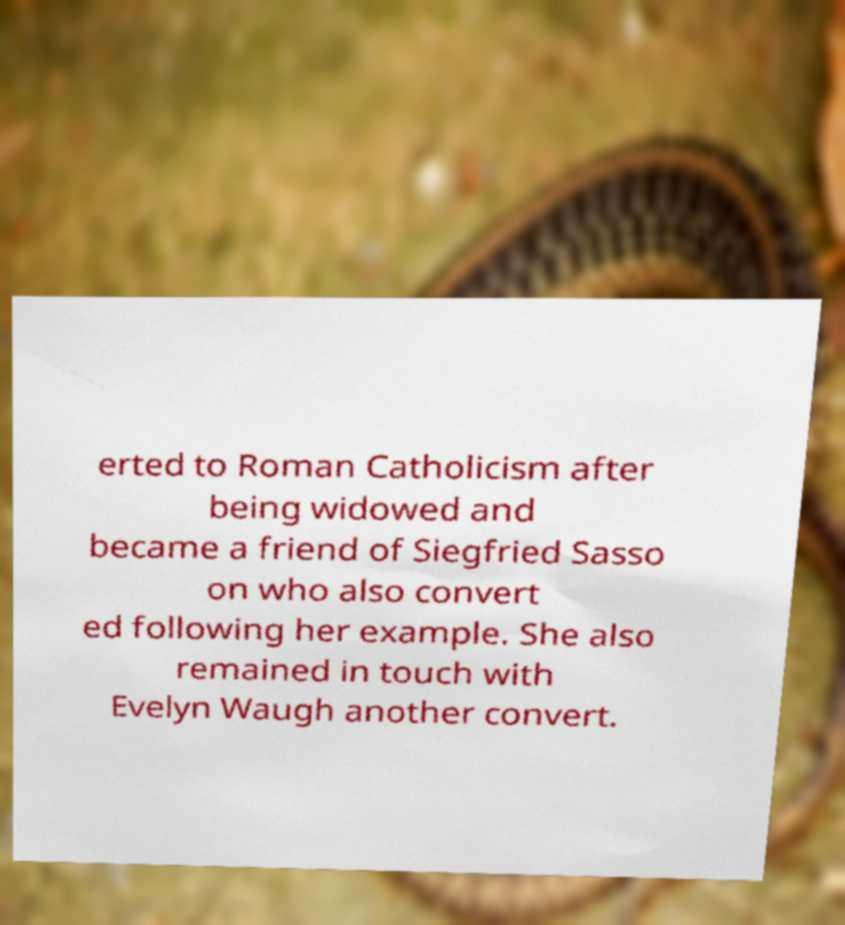Please read and relay the text visible in this image. What does it say? erted to Roman Catholicism after being widowed and became a friend of Siegfried Sasso on who also convert ed following her example. She also remained in touch with Evelyn Waugh another convert. 